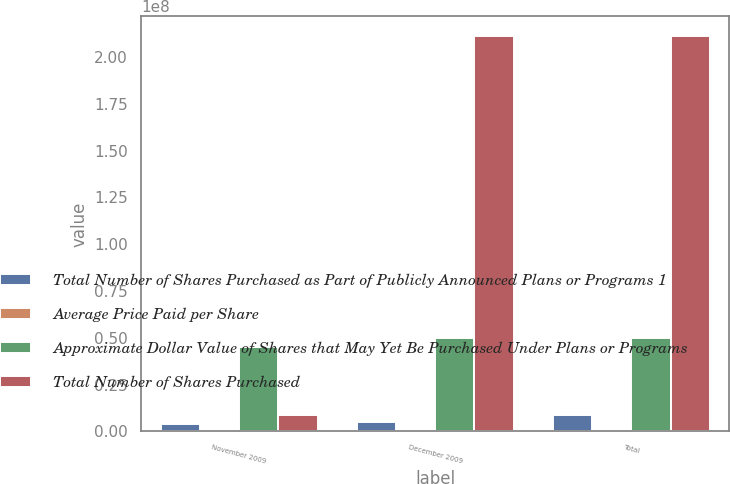Convert chart to OTSL. <chart><loc_0><loc_0><loc_500><loc_500><stacked_bar_chart><ecel><fcel>November 2009<fcel>December 2009<fcel>Total<nl><fcel>Total Number of Shares Purchased as Part of Publicly Announced Plans or Programs 1<fcel>3.8928e+06<fcel>5.05998e+06<fcel>8.95278e+06<nl><fcel>Average Price Paid per Share<fcel>56.88<fcel>58.82<fcel>57.98<nl><fcel>Approximate Dollar Value of Shares that May Yet Be Purchased Under Plans or Programs<fcel>4.48337e+07<fcel>4.98936e+07<fcel>4.98936e+07<nl><fcel>Total Number of Shares Purchased<fcel>8.95278e+06<fcel>2.11111e+08<fcel>2.11111e+08<nl></chart> 